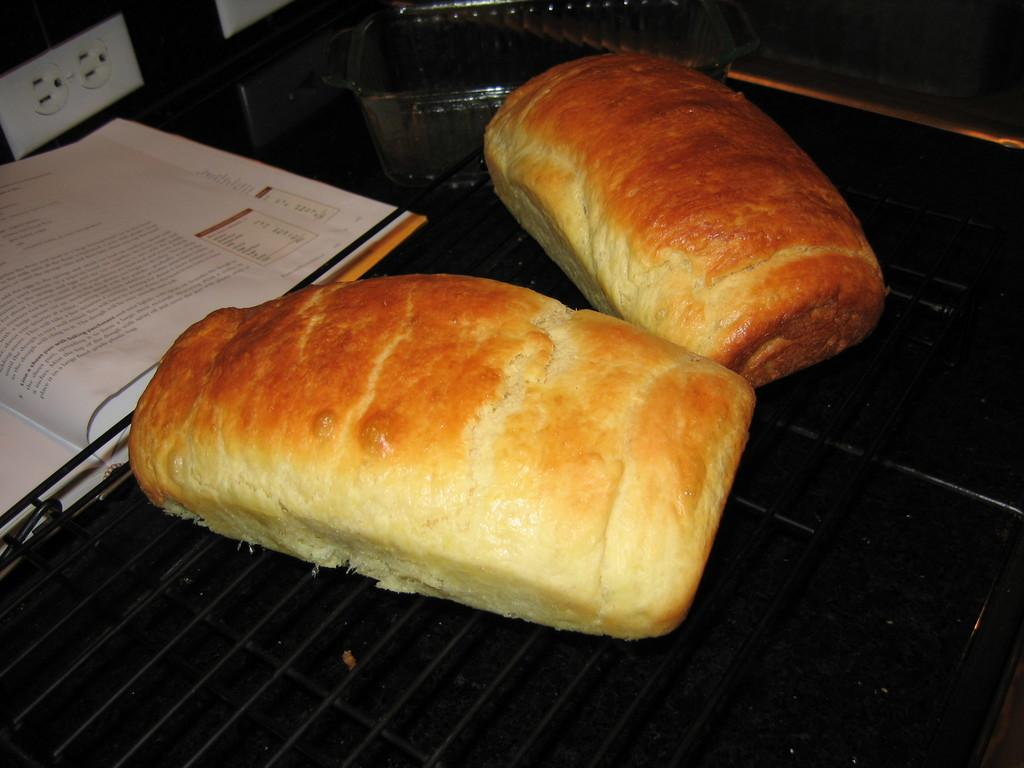What is being cooked on the grill in the image? The image does not show what is being cooked on the grill, only that there are two braids on the grill. What can be seen towards the left side of the image? There is a book towards the left side of the image. What is located at the top of the image? There is a bowl and a switch board at the top of the image. What type of nose can be seen on the bike in the image? There is no bike present in the image, and therefore no nose to observe. Can you describe the flight of the birds in the image? There are no birds or flight depicted in the image. 